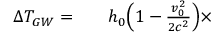Convert formula to latex. <formula><loc_0><loc_0><loc_500><loc_500>\begin{array} { r l r } { \Delta T _ { G W } = } & { h _ { 0 } \left ( 1 - \frac { v _ { 0 } ^ { 2 } } { 2 c ^ { 2 } } \right ) \times } \end{array}</formula> 